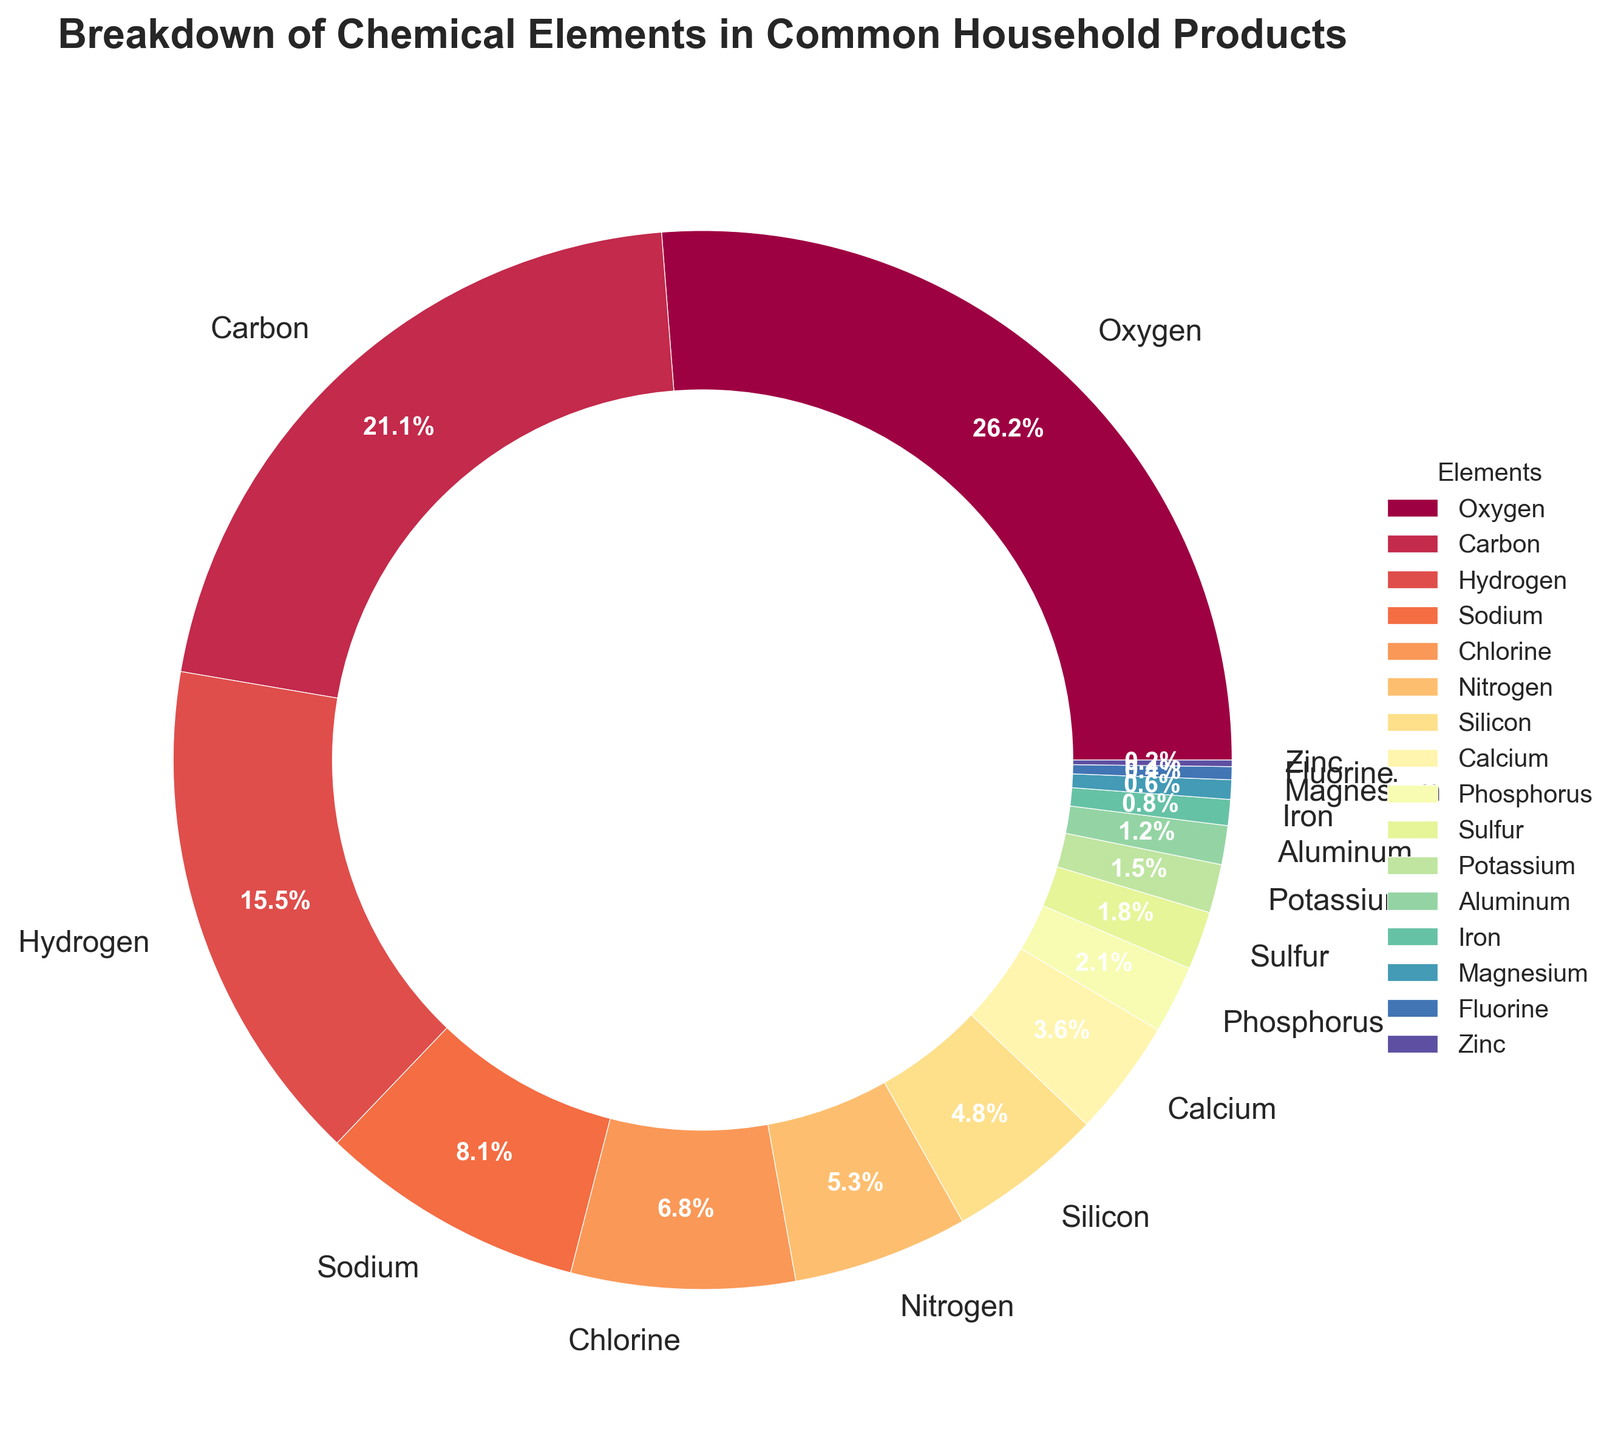Which element has the highest percentage in common household products? Observing the pie chart, the largest section represents the highest percentage, which is visually identified as Oxygen
Answer: Oxygen What is the combined percentage of Carbon and Hydrogen? By adding their percentages from the chart: Carbon (21.3%) + Hydrogen (15.7%) = 37.0%
Answer: 37.0% How does the percentage of Sodium compare to that of Chlorine? The chart shows Sodium at 8.2% and Chlorine slightly lower at 6.9%. Sodium has a higher percentage than Chlorine
Answer: Sodium has a higher percentage Are there more elements above 10% or below 10%? Identifying elements by percentage: Only Oxygen (26.5%) is above 10%, all others are below. Hence, there are more elements below 10%
Answer: Below 10% Which two elements have the smallest percentages and what are their values? Based on the pie chart, the smallest sections are represented by Zinc (0.2%) and Fluorine (0.4%)
Answer: Zinc (0.2%), Fluorine (0.4%) What is the percentage difference between Nitrogen and Silicon? From the chart, percentages for Nitrogen (5.4%) and Silicon (4.8%) give a difference calculated as 5.4% - 4.8% = 0.6%
Answer: 0.6% Does the combined percentage of Phosphorus, Sulfur, and Potassium surpass that of Carbon? Adding the percentages: Phosphorus (2.1%) + Sulfur (1.8%) + Potassium (1.5%) = 5.4%, which is less than Carbon’s 21.3%
Answer: No What slice of the pie chart represents Calcium and what is its color? Observing the chart, Calcium (3.6%) is depicted in a distinctive color within the pie. The color might be from a warm or cool spectrum depending on the palette used (e.g., a shade close to the middle of the color gradient)
Answer: 3.6%, a specific shade within the pie chart’s gradient How do the percentages of Aluminum and Iron together compare with Silicon’s percentage? Calculation shows Aluminum (1.2%) + Iron (0.8%) = 2.0%, which is less than Silicon’s 4.8%
Answer: Less than Silicon What is the average percentage of the elements Sodium, Chlorine, and Nitrogen? Calculating the mean: (Sodium 8.2% + Chlorine 6.9% + Nitrogen 5.4%) / 3 = (20.5%) / 3 = 6.83%
Answer: 6.83% 